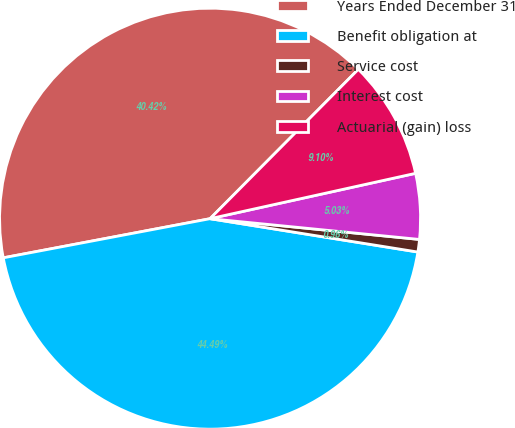Convert chart to OTSL. <chart><loc_0><loc_0><loc_500><loc_500><pie_chart><fcel>Years Ended December 31<fcel>Benefit obligation at<fcel>Service cost<fcel>Interest cost<fcel>Actuarial (gain) loss<nl><fcel>40.42%<fcel>44.49%<fcel>0.96%<fcel>5.03%<fcel>9.1%<nl></chart> 